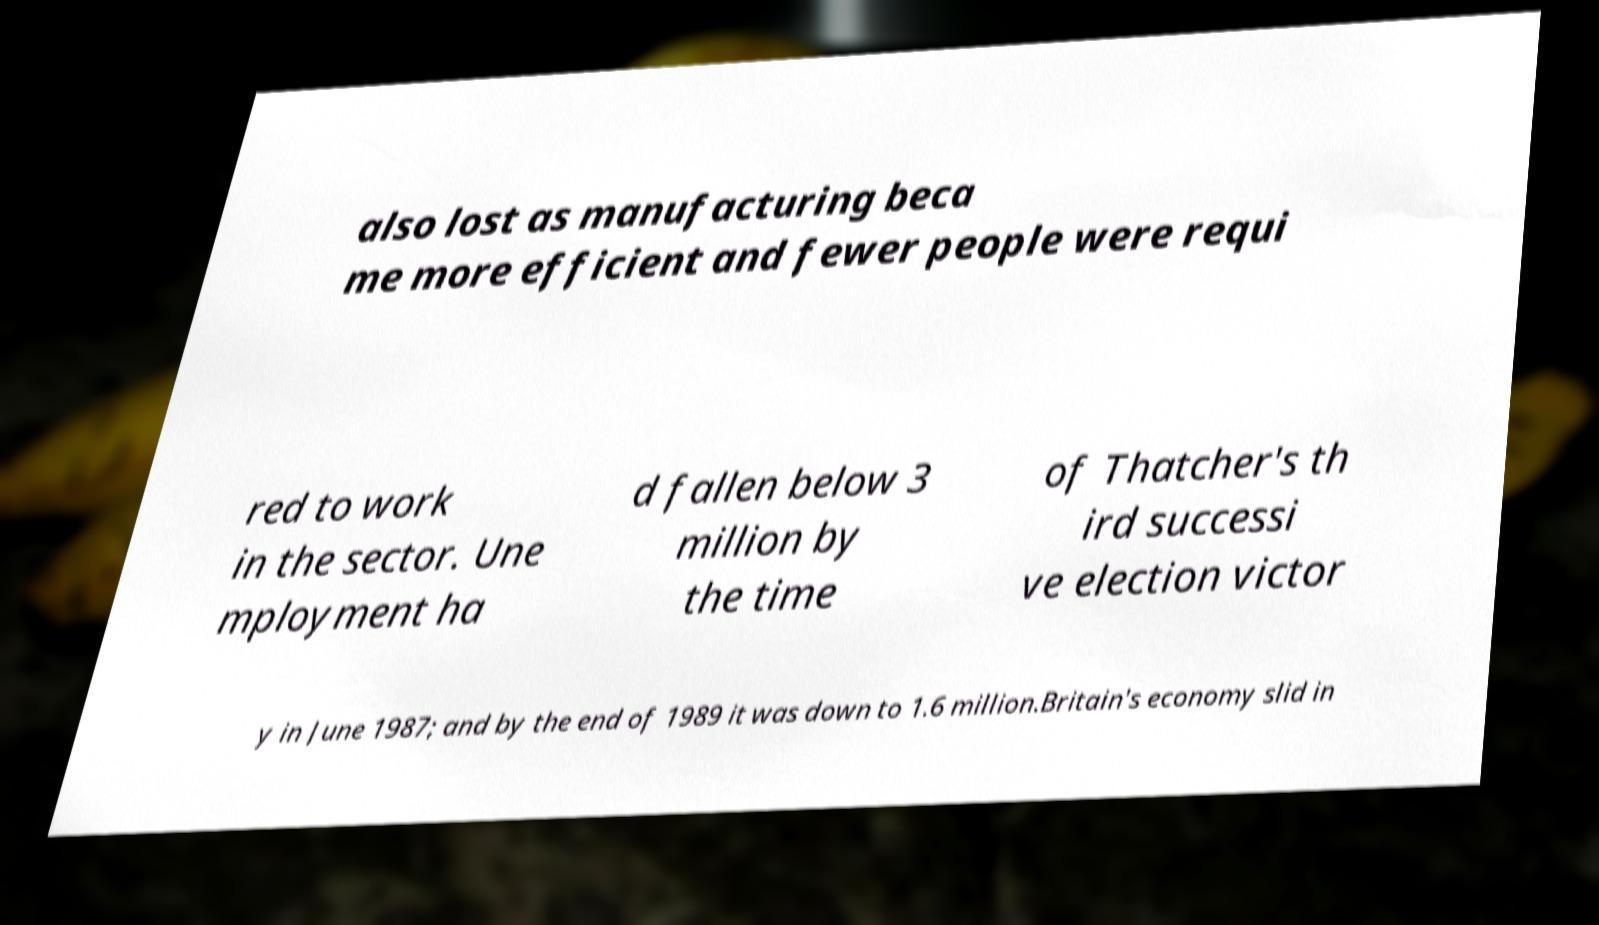Please identify and transcribe the text found in this image. also lost as manufacturing beca me more efficient and fewer people were requi red to work in the sector. Une mployment ha d fallen below 3 million by the time of Thatcher's th ird successi ve election victor y in June 1987; and by the end of 1989 it was down to 1.6 million.Britain's economy slid in 